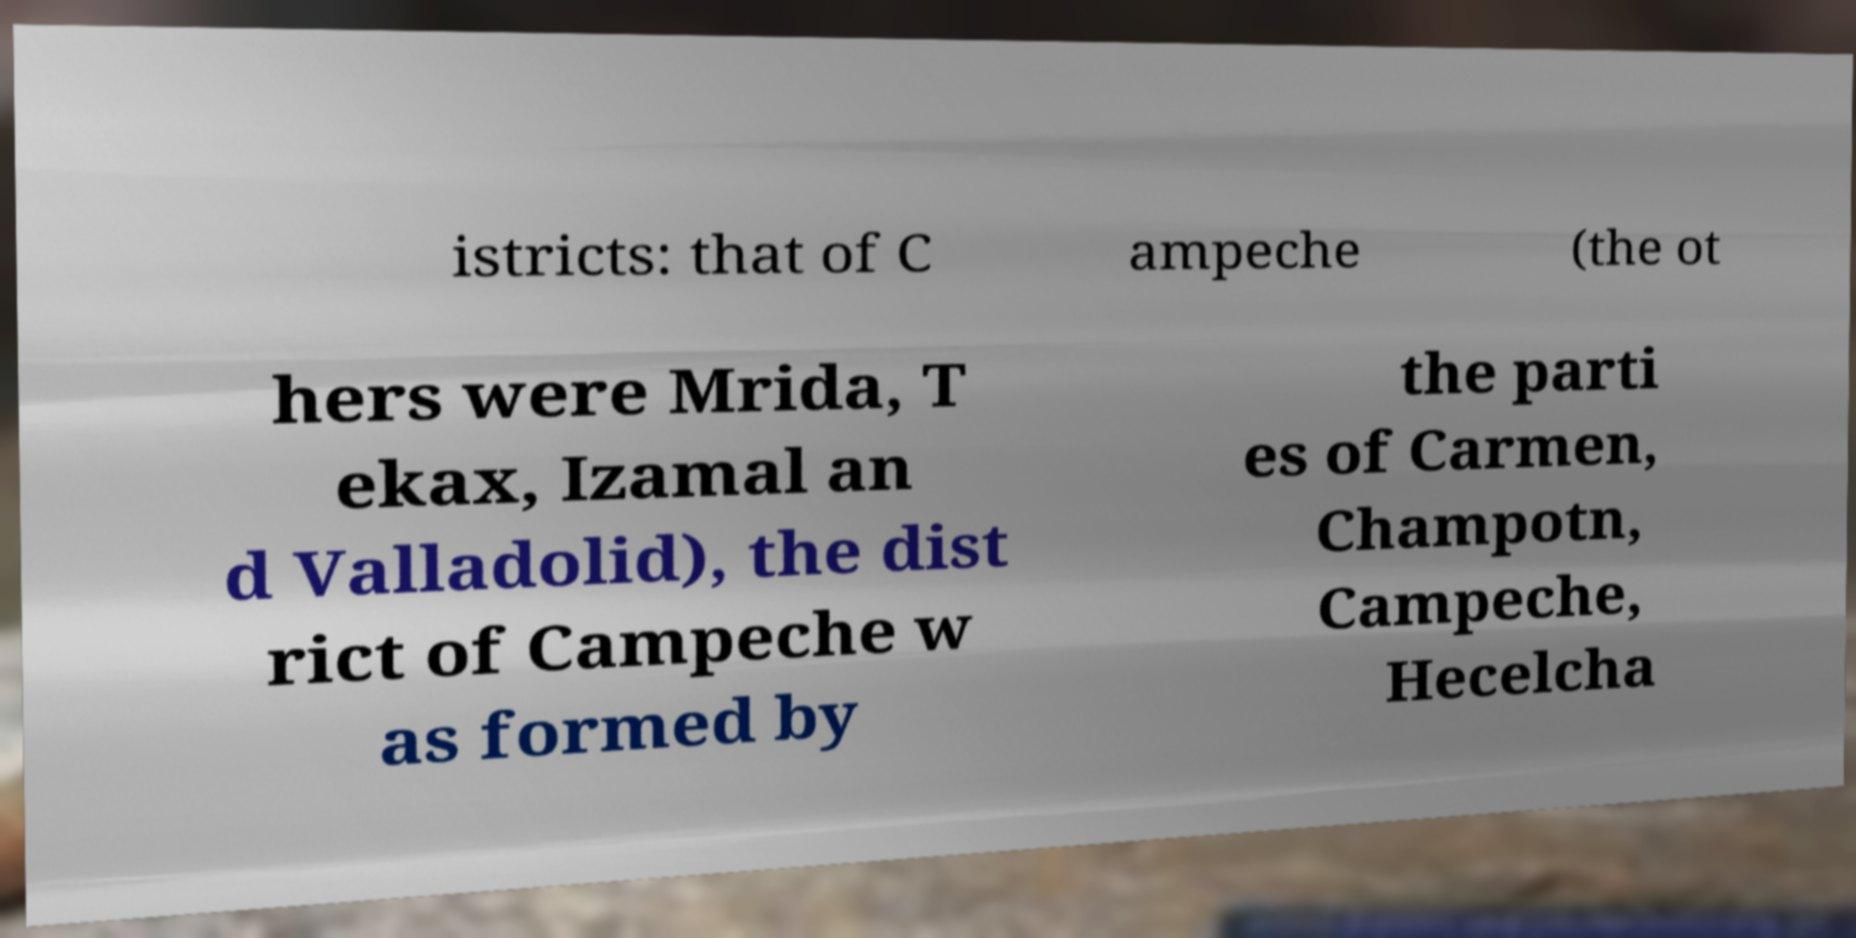Could you assist in decoding the text presented in this image and type it out clearly? istricts: that of C ampeche (the ot hers were Mrida, T ekax, Izamal an d Valladolid), the dist rict of Campeche w as formed by the parti es of Carmen, Champotn, Campeche, Hecelcha 